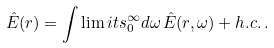<formula> <loc_0><loc_0><loc_500><loc_500>\hat { E } ( r ) = \int \lim i t s _ { 0 } ^ { \infty } d \omega \, \hat { E } ( r , \omega ) + h . c . \, .</formula> 